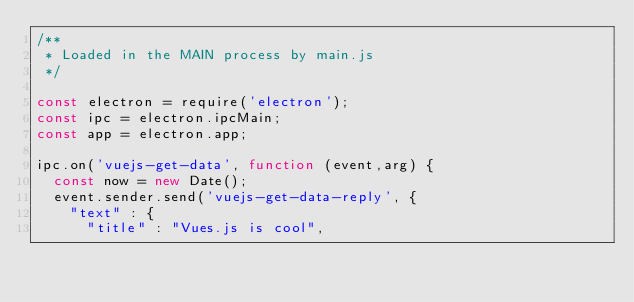Convert code to text. <code><loc_0><loc_0><loc_500><loc_500><_JavaScript_>/**
 * Loaded in the MAIN process by main.js
 */

const electron = require('electron');
const ipc = electron.ipcMain;
const app = electron.app;

ipc.on('vuejs-get-data', function (event,arg) {
  const now = new Date();
  event.sender.send('vuejs-get-data-reply', {
    "text" : {
      "title" : "Vues.js is cool",</code> 